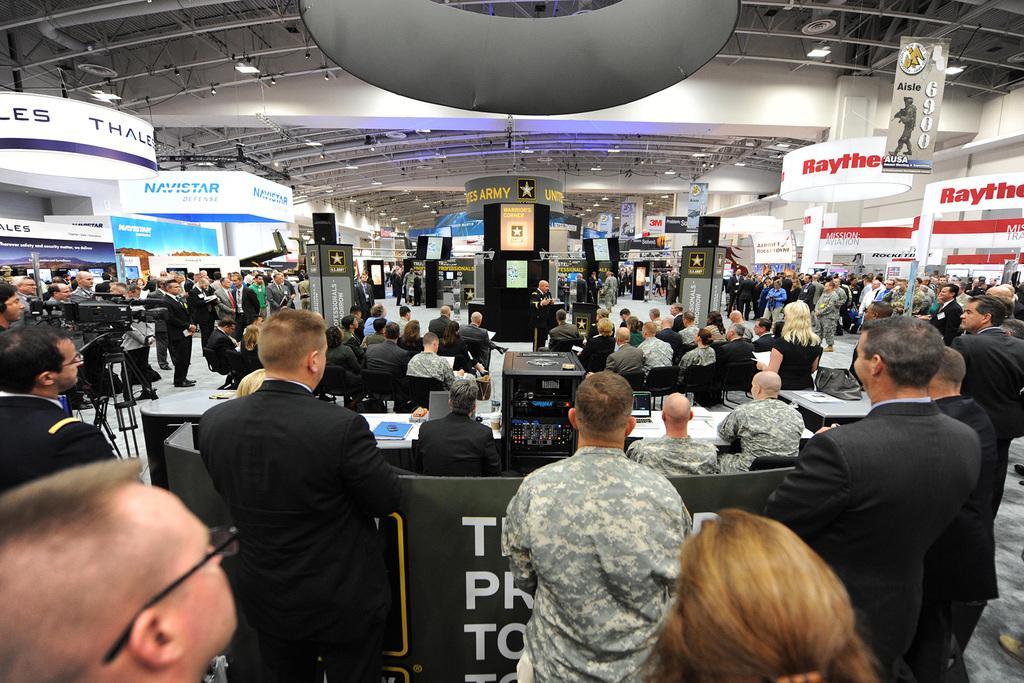Describe this image in one or two sentences. In this image we can see a few people, among them some are standing and some are sitting, there are some tables with some objects on it, at the top of the roof, we can see some metal rods and some boards with text and other objects on the floor. 